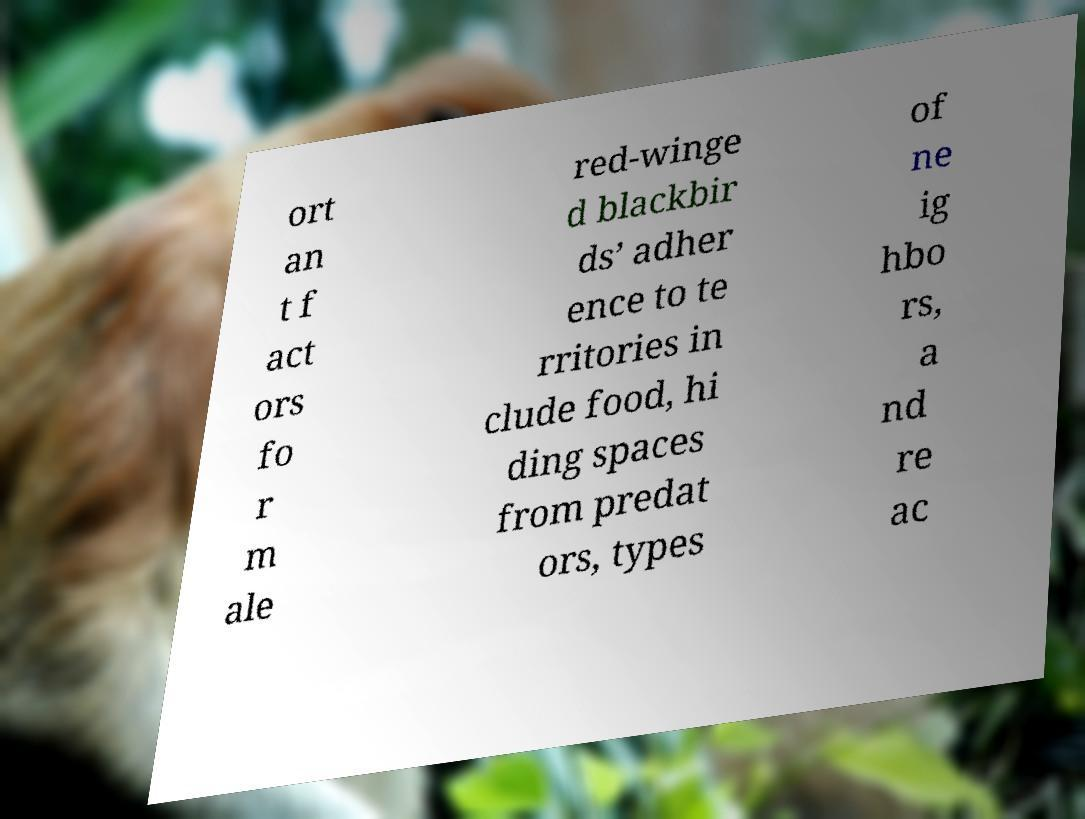Could you assist in decoding the text presented in this image and type it out clearly? ort an t f act ors fo r m ale red-winge d blackbir ds’ adher ence to te rritories in clude food, hi ding spaces from predat ors, types of ne ig hbo rs, a nd re ac 